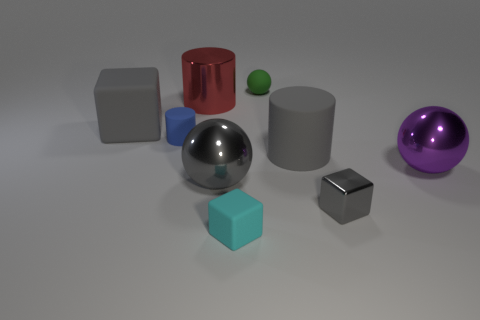Add 1 tiny cubes. How many objects exist? 10 Subtract all cylinders. How many objects are left? 6 Add 1 big gray cylinders. How many big gray cylinders exist? 2 Subtract 0 red spheres. How many objects are left? 9 Subtract all gray metallic blocks. Subtract all small green rubber spheres. How many objects are left? 7 Add 5 big purple objects. How many big purple objects are left? 6 